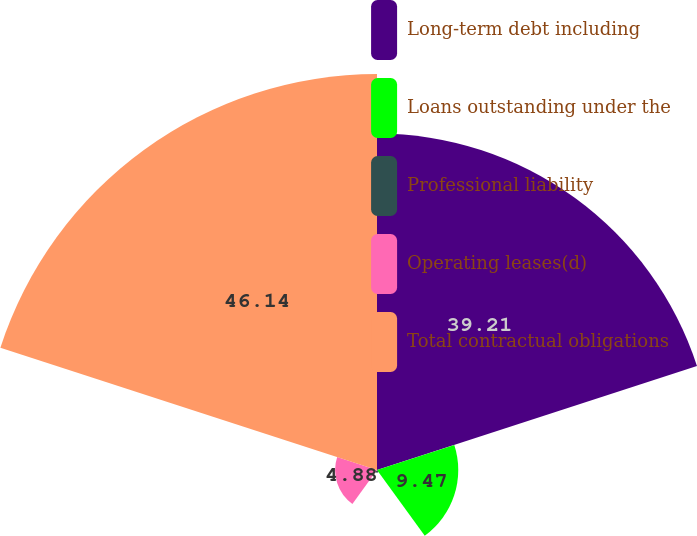Convert chart to OTSL. <chart><loc_0><loc_0><loc_500><loc_500><pie_chart><fcel>Long-term debt including<fcel>Loans outstanding under the<fcel>Professional liability<fcel>Operating leases(d)<fcel>Total contractual obligations<nl><fcel>39.21%<fcel>9.47%<fcel>0.3%<fcel>4.88%<fcel>46.15%<nl></chart> 